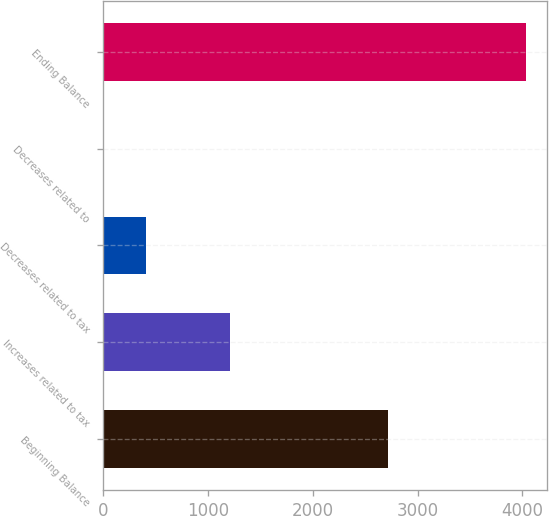Convert chart. <chart><loc_0><loc_0><loc_500><loc_500><bar_chart><fcel>Beginning Balance<fcel>Increases related to tax<fcel>Decreases related to tax<fcel>Decreases related to<fcel>Ending Balance<nl><fcel>2714<fcel>1212.7<fcel>406.9<fcel>4<fcel>4033<nl></chart> 